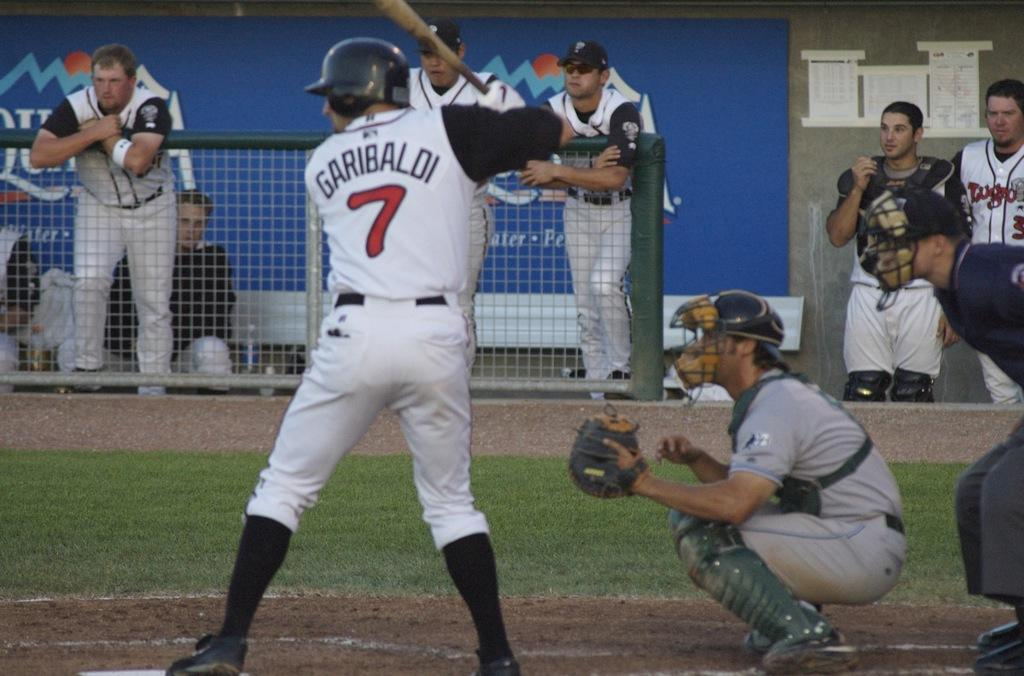<image>
Create a compact narrative representing the image presented. Baseball player wearing number 7 getting ready to bat the ball. 